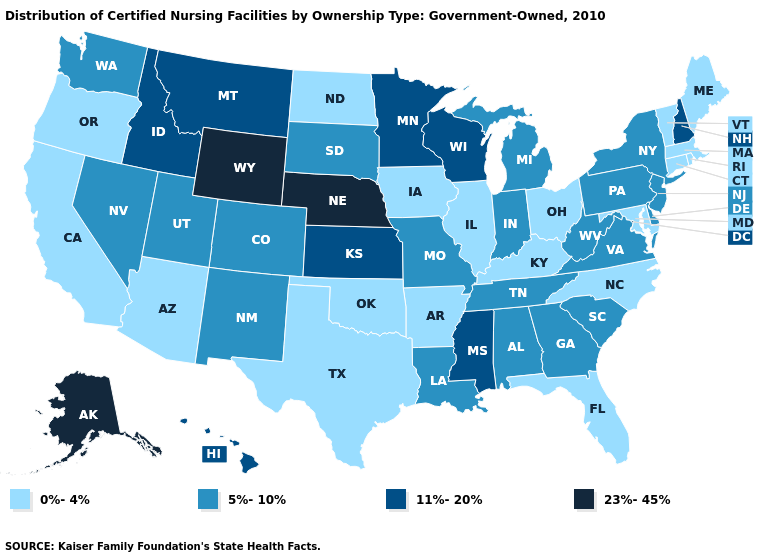What is the value of Montana?
Short answer required. 11%-20%. Name the states that have a value in the range 5%-10%?
Short answer required. Alabama, Colorado, Delaware, Georgia, Indiana, Louisiana, Michigan, Missouri, Nevada, New Jersey, New Mexico, New York, Pennsylvania, South Carolina, South Dakota, Tennessee, Utah, Virginia, Washington, West Virginia. Name the states that have a value in the range 5%-10%?
Short answer required. Alabama, Colorado, Delaware, Georgia, Indiana, Louisiana, Michigan, Missouri, Nevada, New Jersey, New Mexico, New York, Pennsylvania, South Carolina, South Dakota, Tennessee, Utah, Virginia, Washington, West Virginia. What is the lowest value in the USA?
Answer briefly. 0%-4%. What is the lowest value in the Northeast?
Concise answer only. 0%-4%. Among the states that border Michigan , which have the highest value?
Write a very short answer. Wisconsin. Name the states that have a value in the range 23%-45%?
Keep it brief. Alaska, Nebraska, Wyoming. Does the first symbol in the legend represent the smallest category?
Give a very brief answer. Yes. What is the highest value in the MidWest ?
Be succinct. 23%-45%. Which states have the highest value in the USA?
Write a very short answer. Alaska, Nebraska, Wyoming. What is the value of Hawaii?
Answer briefly. 11%-20%. What is the value of New Jersey?
Give a very brief answer. 5%-10%. What is the lowest value in the MidWest?
Answer briefly. 0%-4%. Name the states that have a value in the range 11%-20%?
Short answer required. Hawaii, Idaho, Kansas, Minnesota, Mississippi, Montana, New Hampshire, Wisconsin. 